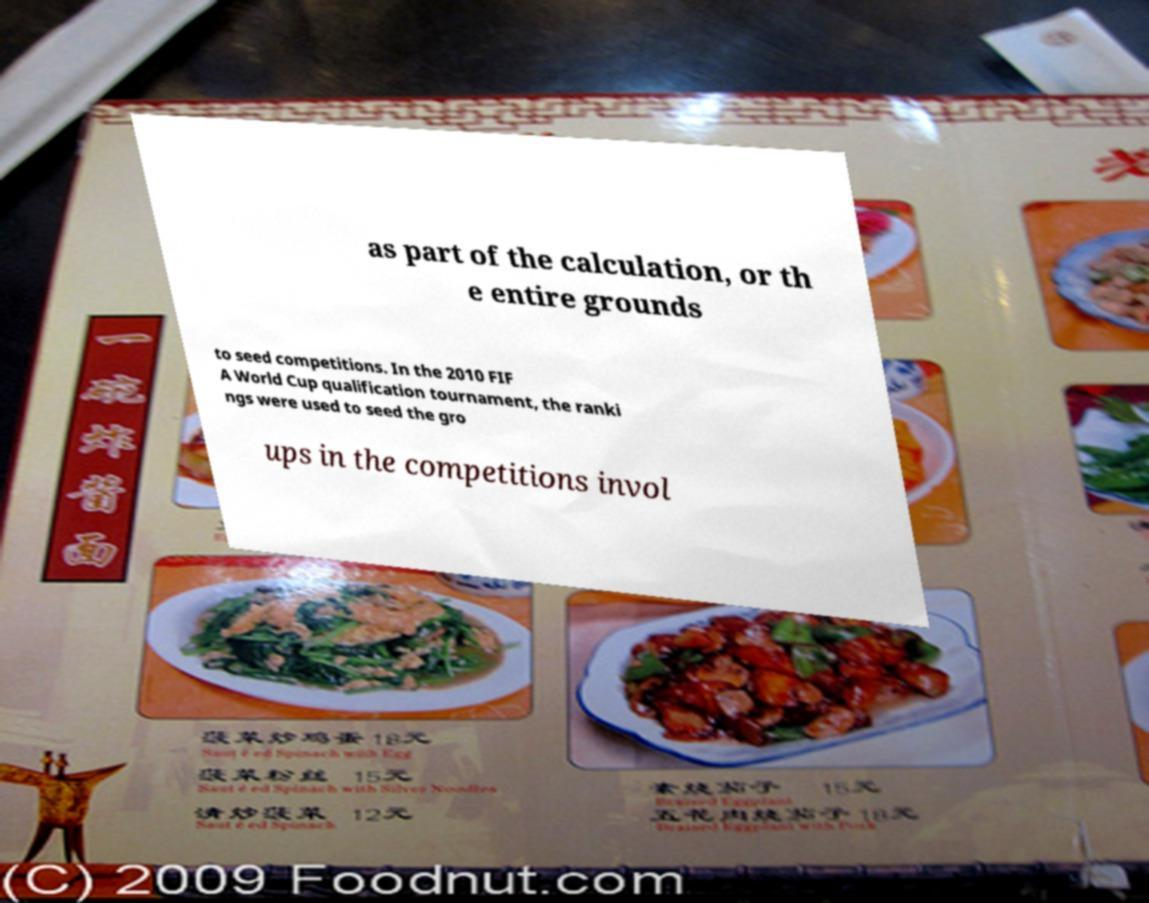Please read and relay the text visible in this image. What does it say? as part of the calculation, or th e entire grounds to seed competitions. In the 2010 FIF A World Cup qualification tournament, the ranki ngs were used to seed the gro ups in the competitions invol 